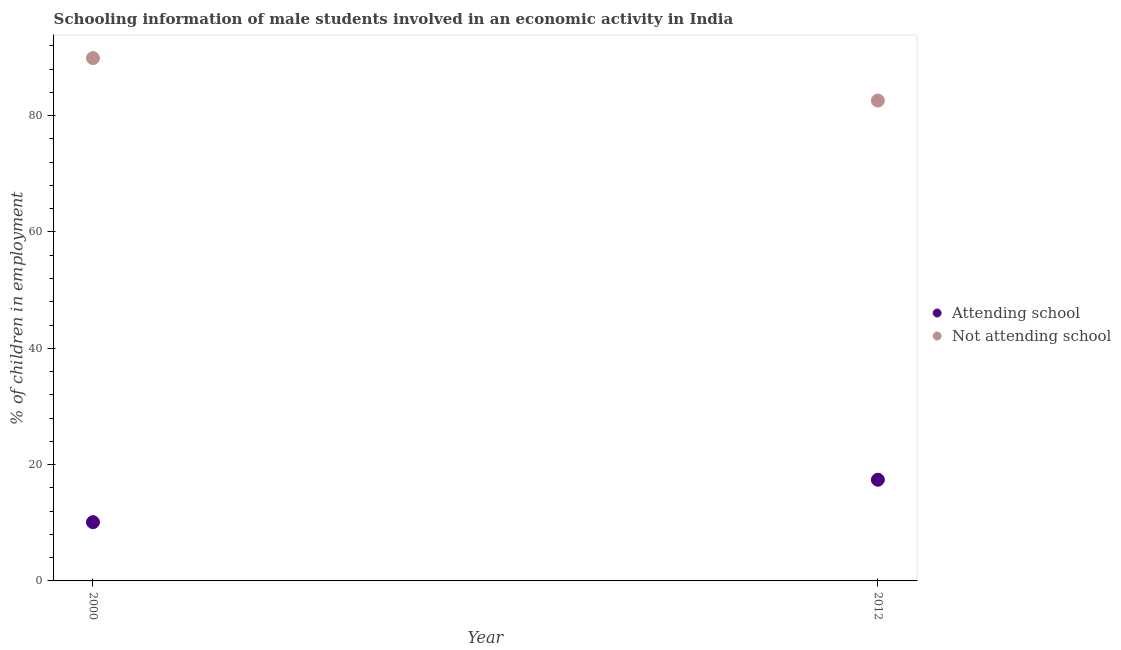How many different coloured dotlines are there?
Make the answer very short. 2. Is the number of dotlines equal to the number of legend labels?
Give a very brief answer. Yes. What is the total percentage of employed males who are attending school in the graph?
Offer a very short reply. 27.5. What is the difference between the percentage of employed males who are not attending school in 2000 and that in 2012?
Provide a succinct answer. 7.3. What is the difference between the percentage of employed males who are attending school in 2012 and the percentage of employed males who are not attending school in 2000?
Your answer should be very brief. -72.5. What is the average percentage of employed males who are attending school per year?
Your response must be concise. 13.75. In the year 2012, what is the difference between the percentage of employed males who are not attending school and percentage of employed males who are attending school?
Provide a short and direct response. 65.2. In how many years, is the percentage of employed males who are attending school greater than 32 %?
Provide a short and direct response. 0. What is the ratio of the percentage of employed males who are not attending school in 2000 to that in 2012?
Your answer should be very brief. 1.09. In how many years, is the percentage of employed males who are not attending school greater than the average percentage of employed males who are not attending school taken over all years?
Your answer should be very brief. 1. Does the percentage of employed males who are not attending school monotonically increase over the years?
Offer a terse response. No. Is the percentage of employed males who are not attending school strictly greater than the percentage of employed males who are attending school over the years?
Provide a short and direct response. Yes. What is the difference between two consecutive major ticks on the Y-axis?
Offer a terse response. 20. Are the values on the major ticks of Y-axis written in scientific E-notation?
Your answer should be very brief. No. Does the graph contain any zero values?
Your answer should be compact. No. Does the graph contain grids?
Ensure brevity in your answer.  No. How many legend labels are there?
Provide a succinct answer. 2. What is the title of the graph?
Provide a short and direct response. Schooling information of male students involved in an economic activity in India. What is the label or title of the X-axis?
Your response must be concise. Year. What is the label or title of the Y-axis?
Give a very brief answer. % of children in employment. What is the % of children in employment of Attending school in 2000?
Keep it short and to the point. 10.1. What is the % of children in employment of Not attending school in 2000?
Your response must be concise. 89.9. What is the % of children in employment in Not attending school in 2012?
Give a very brief answer. 82.6. Across all years, what is the maximum % of children in employment of Attending school?
Your response must be concise. 17.4. Across all years, what is the maximum % of children in employment of Not attending school?
Offer a terse response. 89.9. Across all years, what is the minimum % of children in employment of Not attending school?
Keep it short and to the point. 82.6. What is the total % of children in employment in Not attending school in the graph?
Give a very brief answer. 172.5. What is the difference between the % of children in employment in Attending school in 2000 and that in 2012?
Provide a succinct answer. -7.3. What is the difference between the % of children in employment of Not attending school in 2000 and that in 2012?
Provide a short and direct response. 7.3. What is the difference between the % of children in employment in Attending school in 2000 and the % of children in employment in Not attending school in 2012?
Provide a short and direct response. -72.5. What is the average % of children in employment in Attending school per year?
Keep it short and to the point. 13.75. What is the average % of children in employment of Not attending school per year?
Offer a terse response. 86.25. In the year 2000, what is the difference between the % of children in employment of Attending school and % of children in employment of Not attending school?
Your response must be concise. -79.8. In the year 2012, what is the difference between the % of children in employment in Attending school and % of children in employment in Not attending school?
Your answer should be very brief. -65.2. What is the ratio of the % of children in employment in Attending school in 2000 to that in 2012?
Keep it short and to the point. 0.58. What is the ratio of the % of children in employment of Not attending school in 2000 to that in 2012?
Offer a very short reply. 1.09. What is the difference between the highest and the lowest % of children in employment in Attending school?
Your response must be concise. 7.3. What is the difference between the highest and the lowest % of children in employment of Not attending school?
Provide a short and direct response. 7.3. 